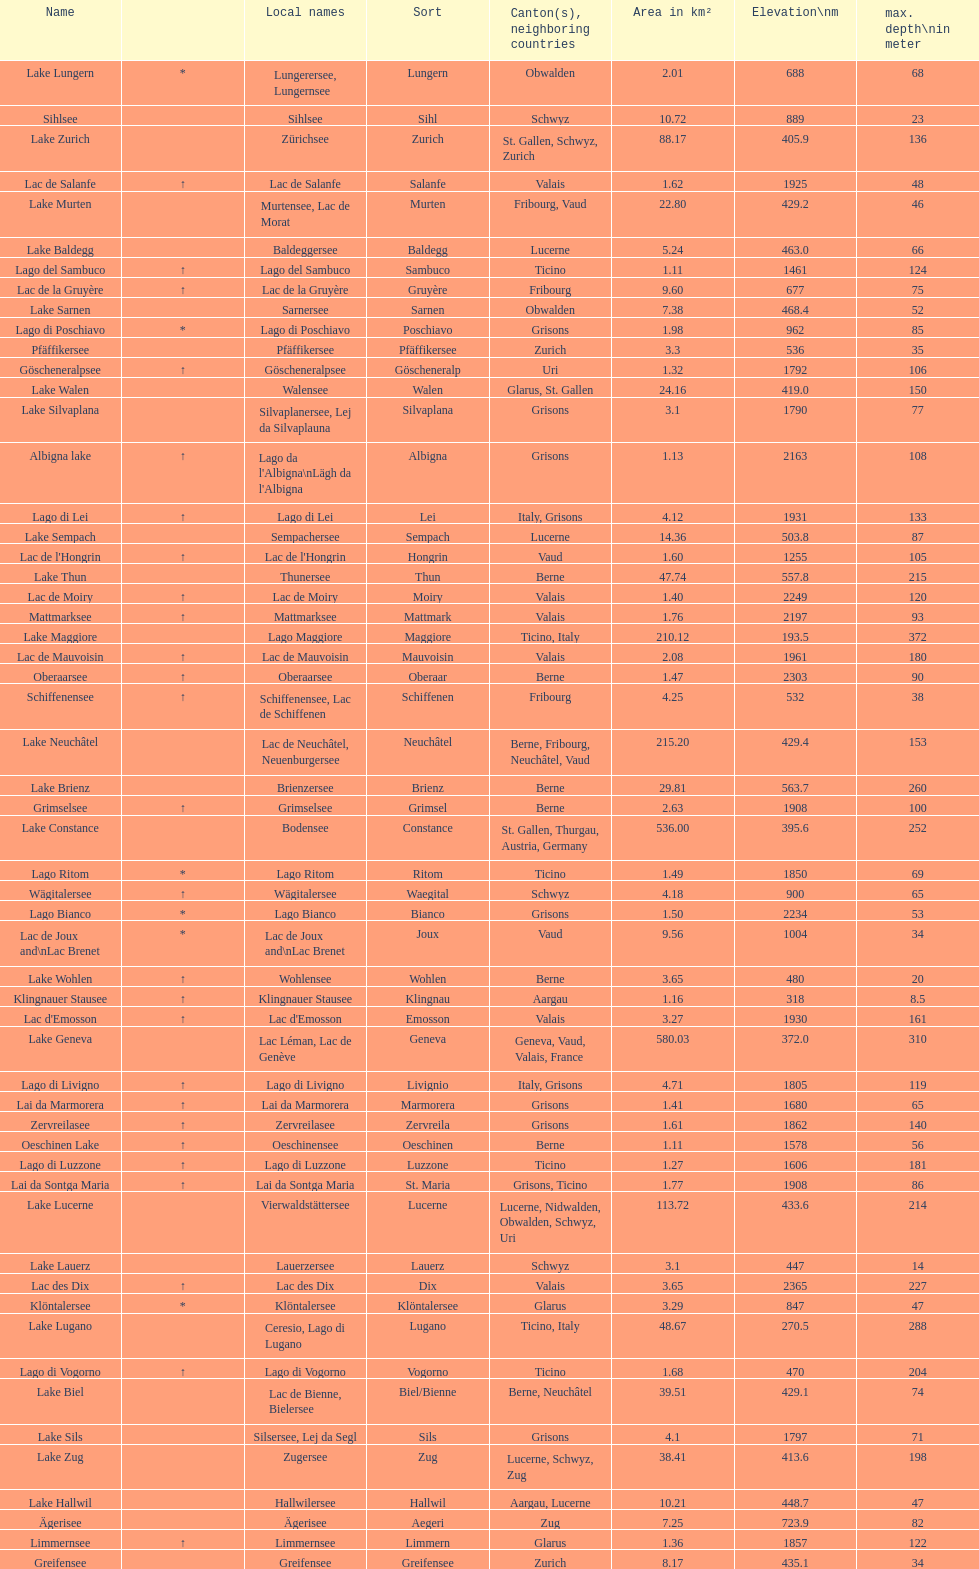What is the deepest lake? Lake Maggiore. 